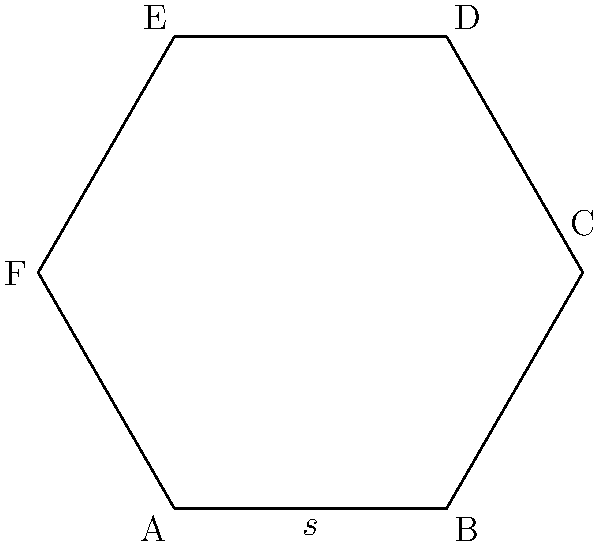In the pursuit of maintaining precise records, you are tasked with calculating the area of a regular hexagonal plot of land. The side length of this hexagon is 2 units. Using your knowledge of geometry and ethical precision, determine the exact area of this hexagonal plot. Let's approach this step-by-step, ensuring accuracy at each stage:

1) The formula for the area of a regular hexagon is:

   $$A = \frac{3\sqrt{3}}{2}s^2$$

   where $s$ is the side length.

2) We are given that the side length $s = 2$ units.

3) Let's substitute this into our formula:

   $$A = \frac{3\sqrt{3}}{2}(2^2)$$

4) Simplify the expression inside the parentheses:

   $$A = \frac{3\sqrt{3}}{2}(4)$$

5) Multiply:

   $$A = 6\sqrt{3}$$

6) This is our final answer in exact form. If we were to approximate this:

   $$A \approx 10.3923 \text{ square units}$$

   However, as a matter of ethical precision, it's important to keep the exact form unless specifically requested otherwise.
Answer: $6\sqrt{3}$ square units 